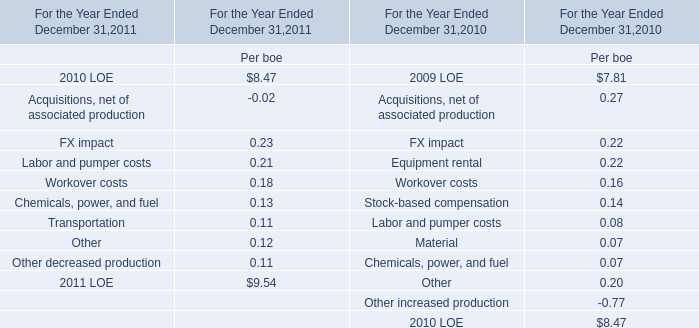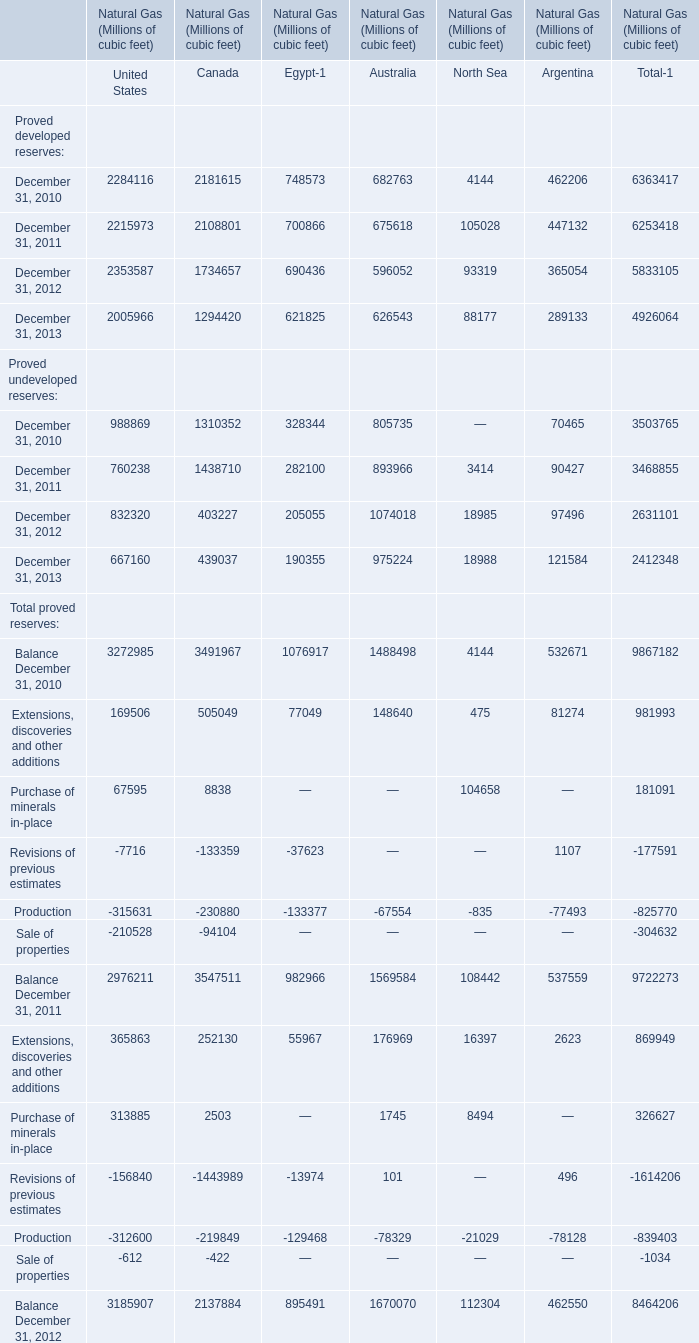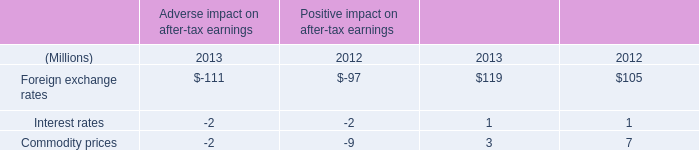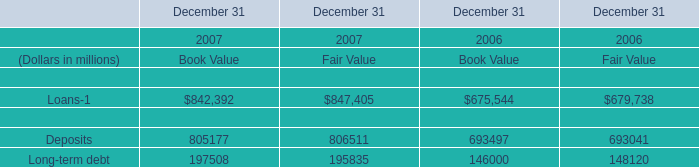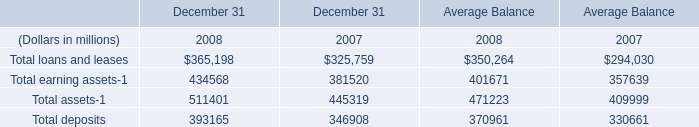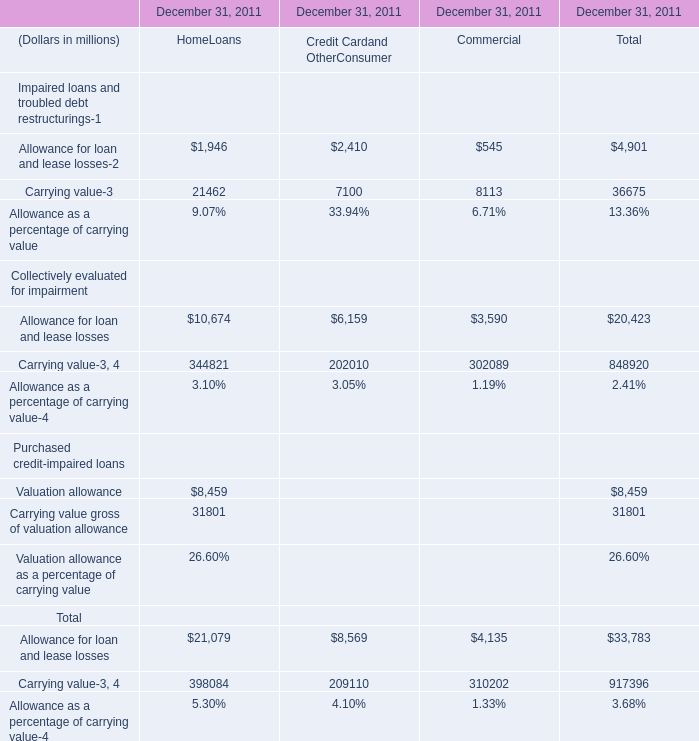In the year with the most Proved developed reserves of United States, what is the growth rate of Proved developed reserves of Canada? 
Computations: ((1734657 - 2108801) / 2108801)
Answer: -0.17742. 